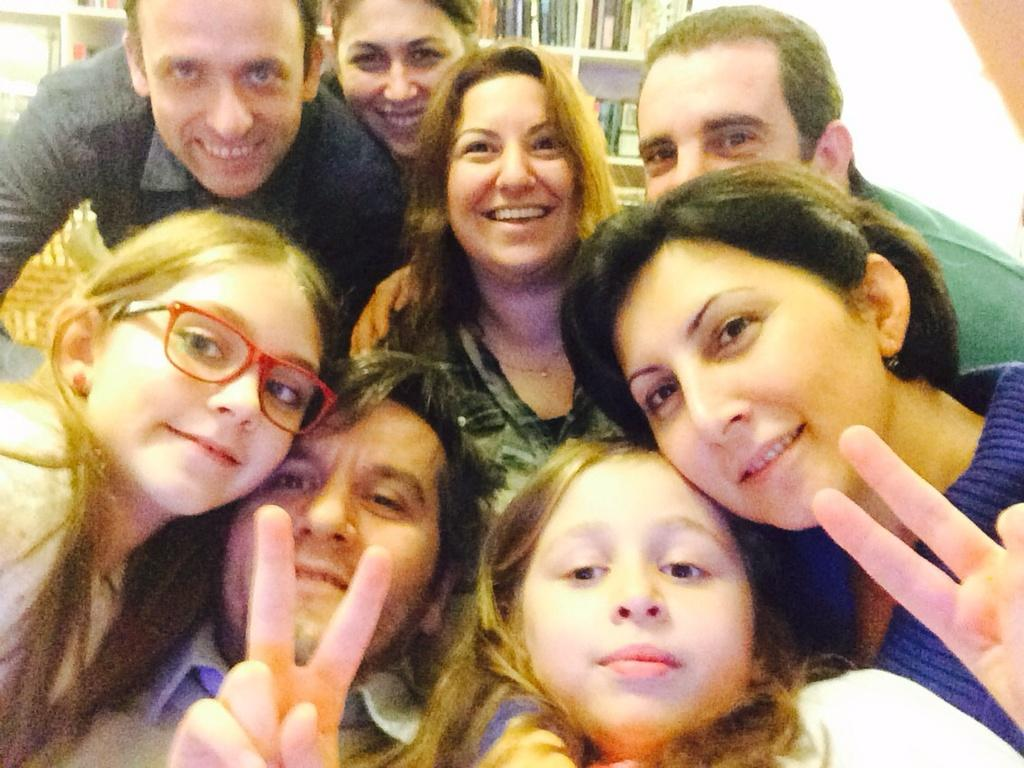How many people are in the image? There are persons in the image, but the exact number is not specified. What is the facial expression of the persons in the image? The persons in the image are smiling. What can be seen in the background of the image? There is a rack in the background of the image. What is on the rack in the background? There are books on the rack in the background. What type of yam is being used to measure the expansion of the books on the rack? There is no yam present in the image, nor is there any indication of measuring the expansion of the books. 